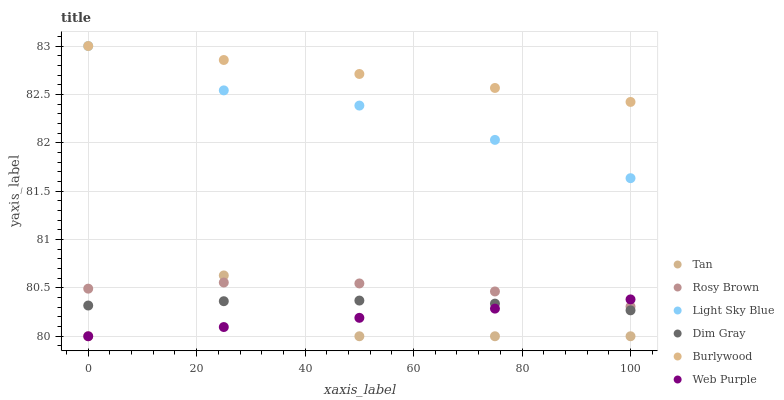Does Tan have the minimum area under the curve?
Answer yes or no. Yes. Does Burlywood have the maximum area under the curve?
Answer yes or no. Yes. Does Rosy Brown have the minimum area under the curve?
Answer yes or no. No. Does Rosy Brown have the maximum area under the curve?
Answer yes or no. No. Is Burlywood the smoothest?
Answer yes or no. Yes. Is Tan the roughest?
Answer yes or no. Yes. Is Rosy Brown the smoothest?
Answer yes or no. No. Is Rosy Brown the roughest?
Answer yes or no. No. Does Web Purple have the lowest value?
Answer yes or no. Yes. Does Rosy Brown have the lowest value?
Answer yes or no. No. Does Light Sky Blue have the highest value?
Answer yes or no. Yes. Does Rosy Brown have the highest value?
Answer yes or no. No. Is Web Purple less than Light Sky Blue?
Answer yes or no. Yes. Is Burlywood greater than Dim Gray?
Answer yes or no. Yes. Does Burlywood intersect Light Sky Blue?
Answer yes or no. Yes. Is Burlywood less than Light Sky Blue?
Answer yes or no. No. Is Burlywood greater than Light Sky Blue?
Answer yes or no. No. Does Web Purple intersect Light Sky Blue?
Answer yes or no. No. 